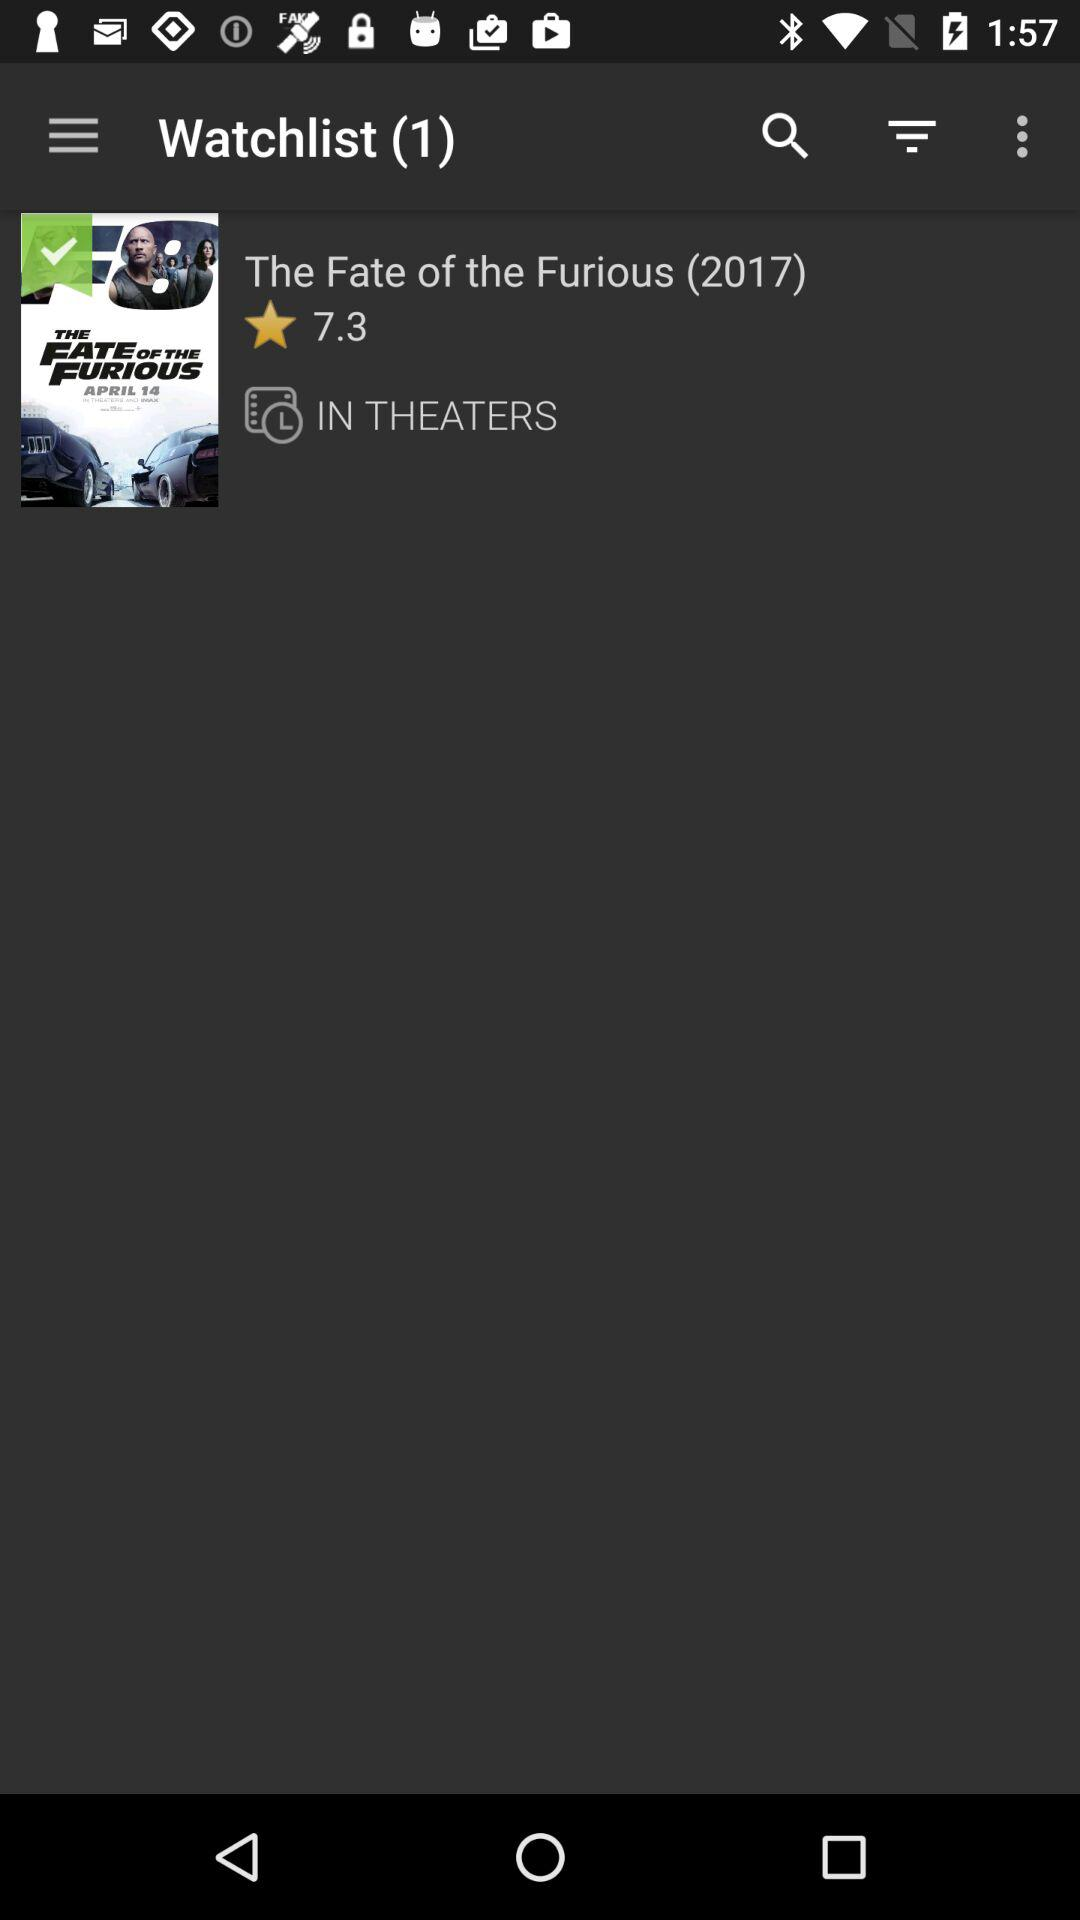What is the rating of The Fate of the Furious?
Answer the question using a single word or phrase. 7.3 